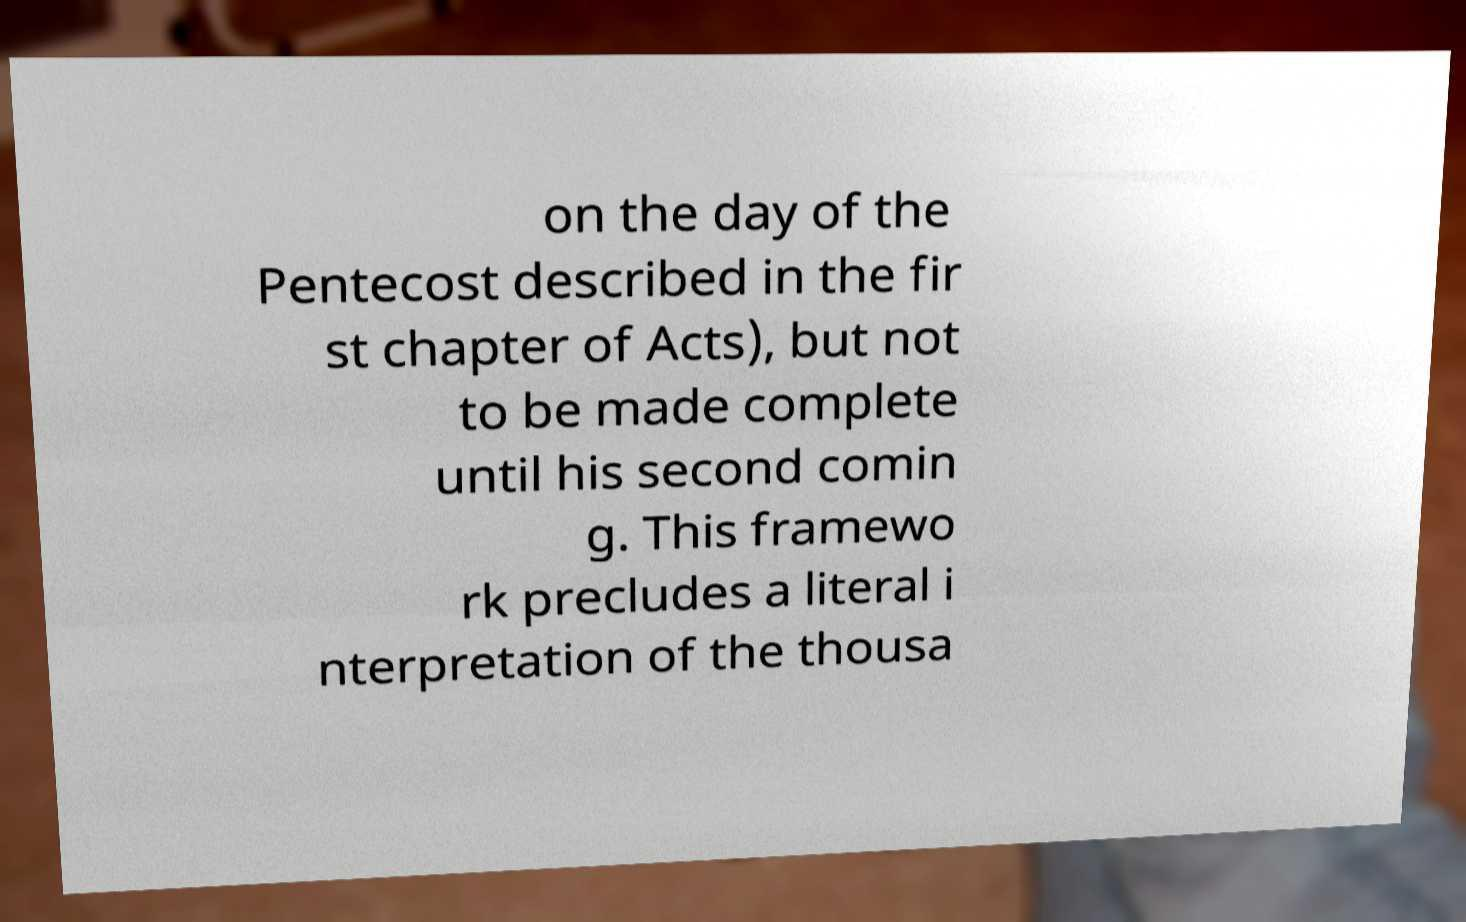I need the written content from this picture converted into text. Can you do that? on the day of the Pentecost described in the fir st chapter of Acts), but not to be made complete until his second comin g. This framewo rk precludes a literal i nterpretation of the thousa 